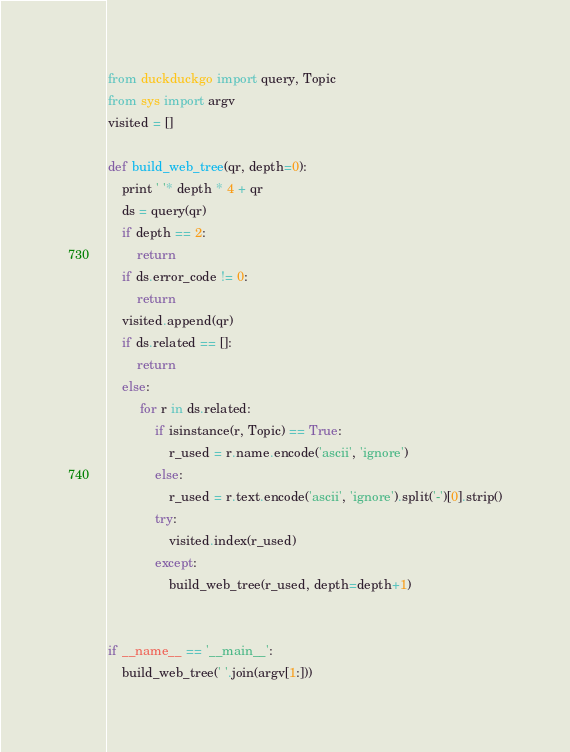<code> <loc_0><loc_0><loc_500><loc_500><_Python_>from duckduckgo import query, Topic
from sys import argv
visited = []

def build_web_tree(qr, depth=0):
    print ' '* depth * 4 + qr
    ds = query(qr)
    if depth == 2:
        return 
    if ds.error_code != 0:
        return 
    visited.append(qr)
    if ds.related == []:
        return 
    else:
         for r in ds.related:
             if isinstance(r, Topic) == True:
                 r_used = r.name.encode('ascii', 'ignore')
             else:
                 r_used = r.text.encode('ascii', 'ignore').split('-')[0].strip()
             try:
                 visited.index(r_used) 
             except:
                 build_web_tree(r_used, depth=depth+1)
         

if __name__ == '__main__':
    build_web_tree(' '.join(argv[1:]))
</code> 